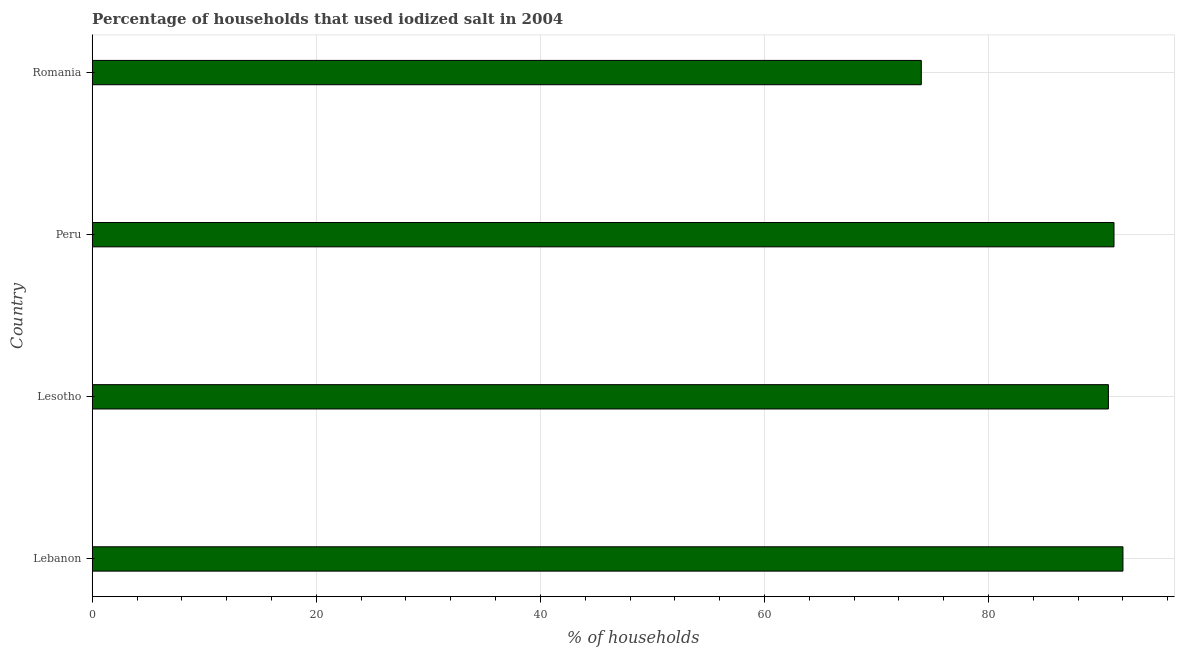Does the graph contain any zero values?
Provide a short and direct response. No. Does the graph contain grids?
Your answer should be compact. Yes. What is the title of the graph?
Your answer should be very brief. Percentage of households that used iodized salt in 2004. What is the label or title of the X-axis?
Your answer should be compact. % of households. What is the label or title of the Y-axis?
Your response must be concise. Country. What is the percentage of households where iodized salt is consumed in Lebanon?
Provide a short and direct response. 92. Across all countries, what is the maximum percentage of households where iodized salt is consumed?
Provide a succinct answer. 92. In which country was the percentage of households where iodized salt is consumed maximum?
Ensure brevity in your answer.  Lebanon. In which country was the percentage of households where iodized salt is consumed minimum?
Offer a very short reply. Romania. What is the sum of the percentage of households where iodized salt is consumed?
Your response must be concise. 347.9. What is the difference between the percentage of households where iodized salt is consumed in Lebanon and Peru?
Your answer should be very brief. 0.8. What is the average percentage of households where iodized salt is consumed per country?
Your answer should be compact. 86.97. What is the median percentage of households where iodized salt is consumed?
Your answer should be compact. 90.95. In how many countries, is the percentage of households where iodized salt is consumed greater than 84 %?
Give a very brief answer. 3. What is the ratio of the percentage of households where iodized salt is consumed in Lebanon to that in Peru?
Your answer should be compact. 1.01. Is the percentage of households where iodized salt is consumed in Lebanon less than that in Romania?
Ensure brevity in your answer.  No. What is the difference between the highest and the lowest percentage of households where iodized salt is consumed?
Offer a very short reply. 18. How many bars are there?
Provide a succinct answer. 4. Are all the bars in the graph horizontal?
Keep it short and to the point. Yes. How many countries are there in the graph?
Ensure brevity in your answer.  4. Are the values on the major ticks of X-axis written in scientific E-notation?
Keep it short and to the point. No. What is the % of households of Lebanon?
Offer a very short reply. 92. What is the % of households of Lesotho?
Your answer should be very brief. 90.7. What is the % of households of Peru?
Keep it short and to the point. 91.2. What is the % of households of Romania?
Offer a very short reply. 74. What is the difference between the % of households in Lebanon and Romania?
Make the answer very short. 18. What is the difference between the % of households in Lesotho and Peru?
Your answer should be compact. -0.5. What is the difference between the % of households in Lesotho and Romania?
Ensure brevity in your answer.  16.7. What is the difference between the % of households in Peru and Romania?
Offer a terse response. 17.2. What is the ratio of the % of households in Lebanon to that in Peru?
Ensure brevity in your answer.  1.01. What is the ratio of the % of households in Lebanon to that in Romania?
Your response must be concise. 1.24. What is the ratio of the % of households in Lesotho to that in Romania?
Offer a very short reply. 1.23. What is the ratio of the % of households in Peru to that in Romania?
Give a very brief answer. 1.23. 